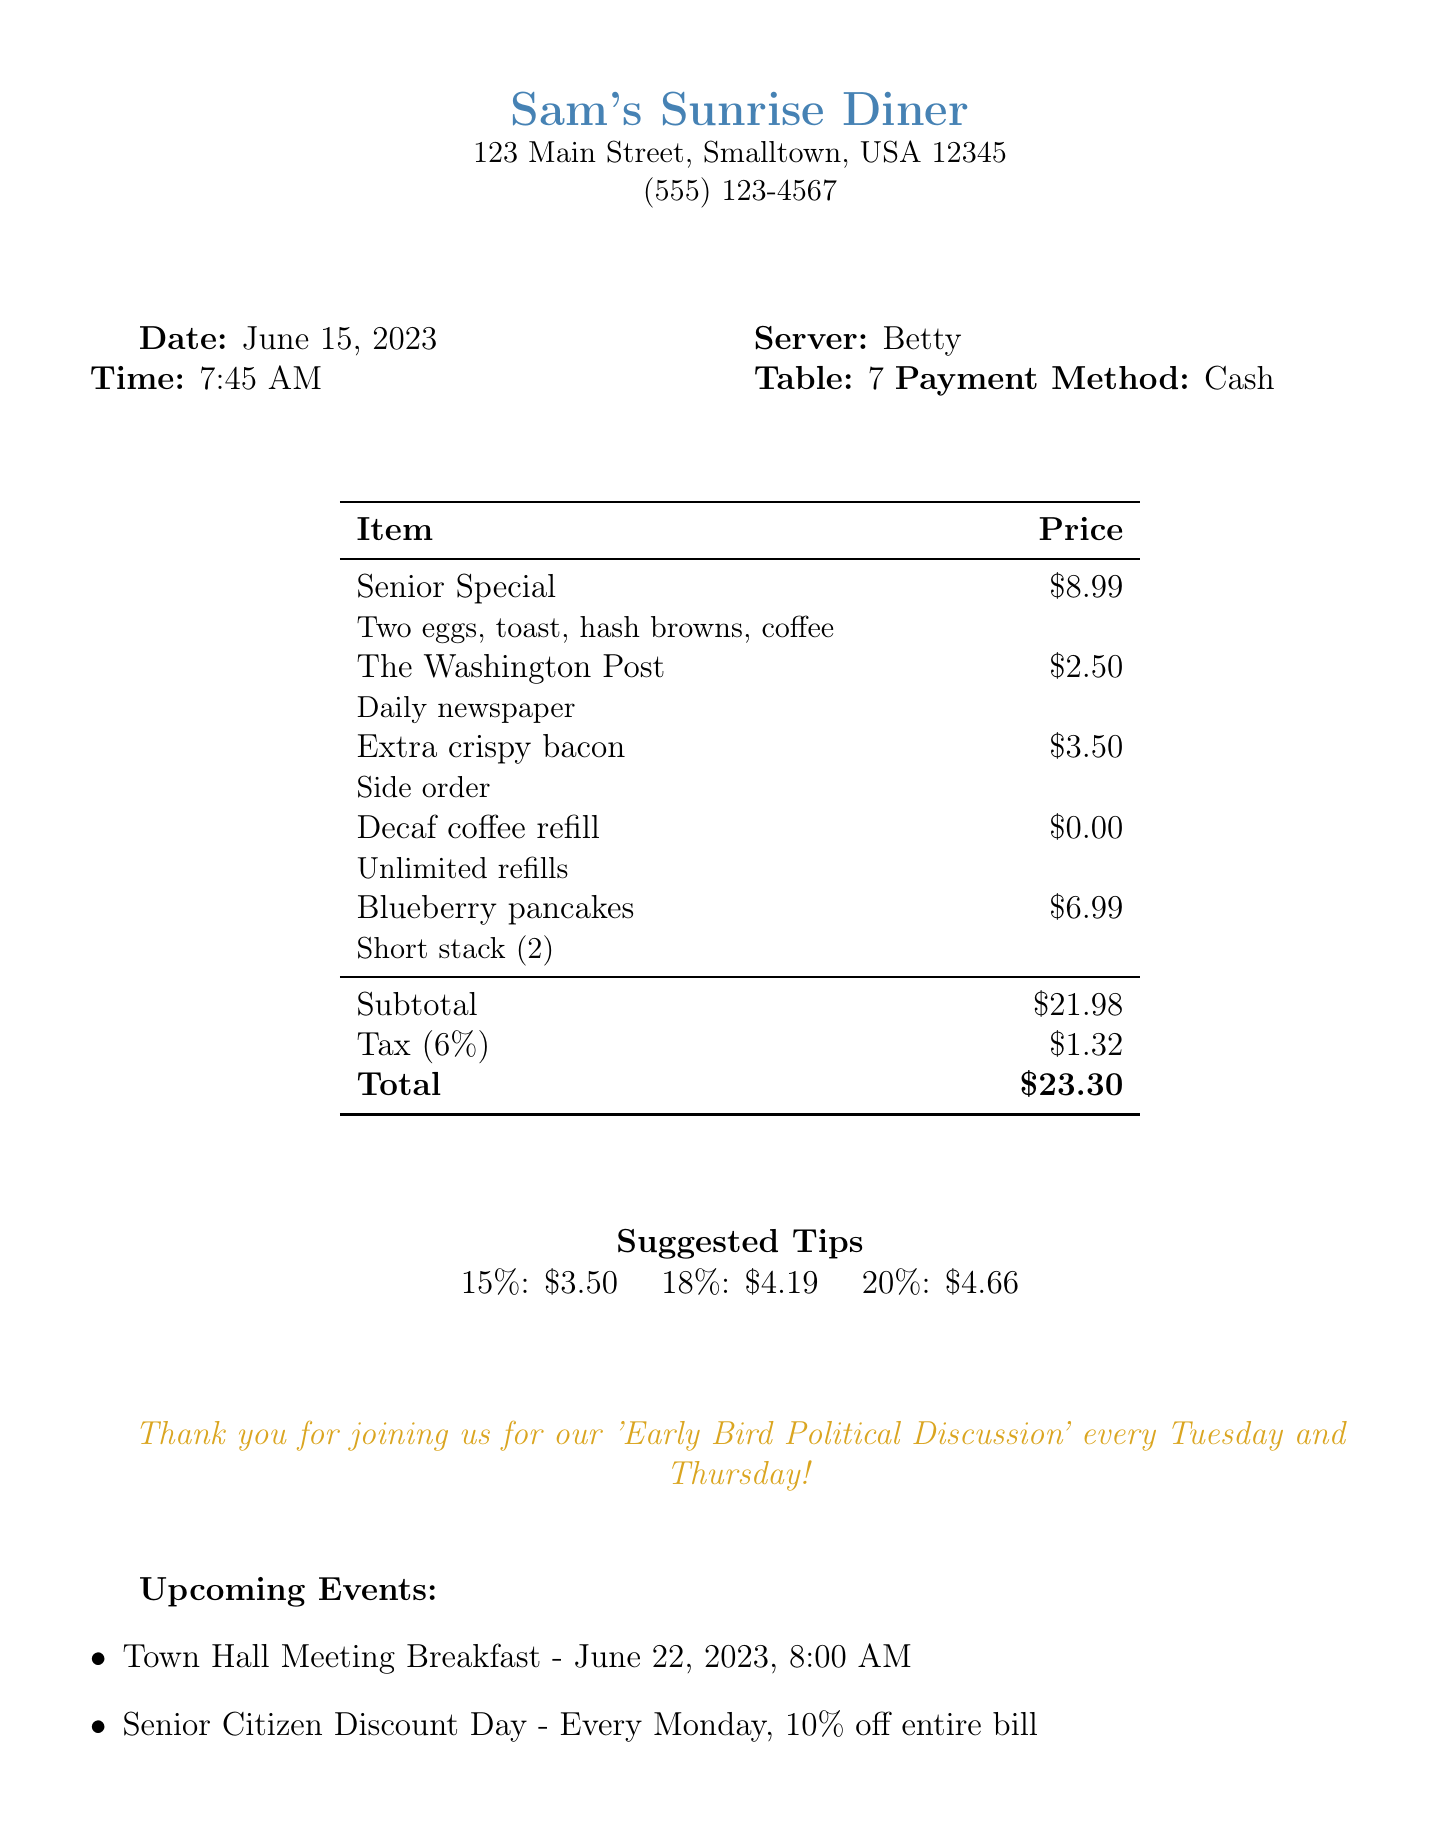What is the name of the diner? The name of the diner is prominently displayed at the top of the document.
Answer: Sam's Sunrise Diner What was the date of the meal? The date is specified in the header section of the document.
Answer: June 15, 2023 Who was the server for this meal? The server's name is listed in the details of the invoice.
Answer: Betty What is the total amount due? The total amount is clearly stated at the bottom of the invoice.
Answer: $23.30 What is the percentage for the suggested tip that amounts to $4.19? The document lists suggested tip percentages along with their respective amounts.
Answer: 18% How much did the extra crispy bacon cost? The price for the extra crispy bacon is included with the item description.
Answer: $3.50 What is the tax rate applied to the bill? The tax rate is specified in the bill details section.
Answer: 6% What special event is mentioned for June 22, 2023? The upcoming event is outlined in the section dedicated to future gatherings.
Answer: Town Hall Meeting Breakfast What is the discount for Senior Citizen Discount Day? The discount offered on this day is mentioned directly in the document.
Answer: 10% off entire bill What payment method was used for this transaction? The payment method is noted in the details section of the invoice.
Answer: Cash 